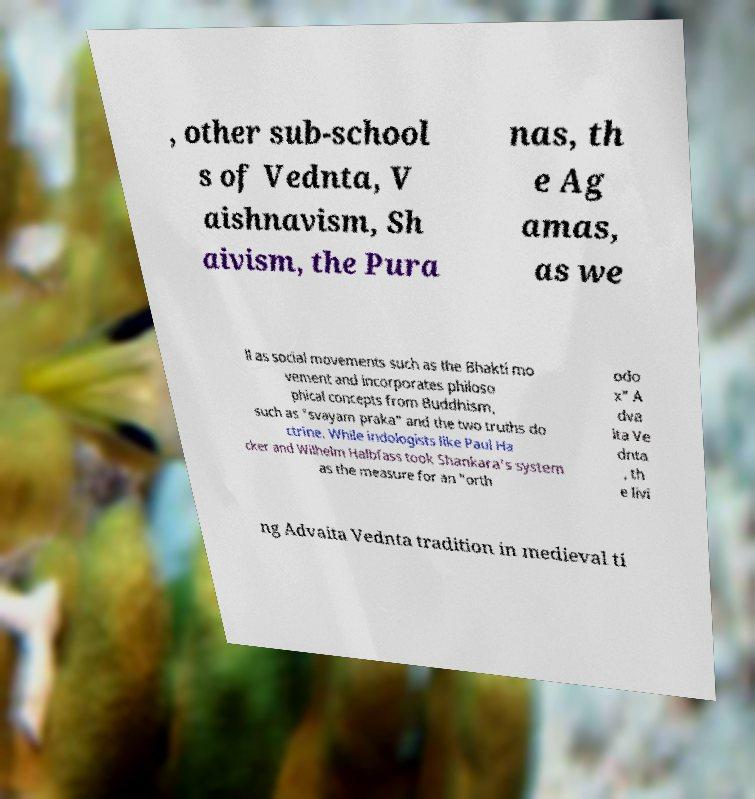There's text embedded in this image that I need extracted. Can you transcribe it verbatim? , other sub-school s of Vednta, V aishnavism, Sh aivism, the Pura nas, th e Ag amas, as we ll as social movements such as the Bhakti mo vement and incorporates philoso phical concepts from Buddhism, such as "svayam praka" and the two truths do ctrine. While indologists like Paul Ha cker and Wilhelm Halbfass took Shankara's system as the measure for an "orth odo x" A dva ita Ve dnta , th e livi ng Advaita Vednta tradition in medieval ti 